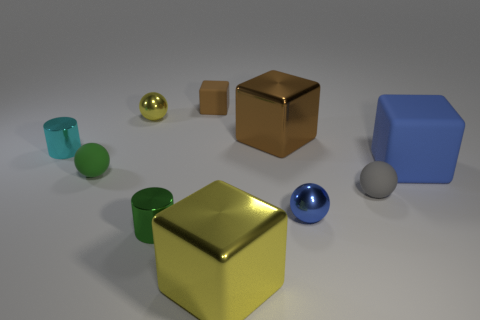There is a cyan object; what shape is it?
Give a very brief answer. Cylinder. What number of small green spheres are on the left side of the small metallic cylinder to the right of the small sphere behind the tiny green ball?
Provide a short and direct response. 1. What number of other objects are the same material as the tiny yellow thing?
Your answer should be very brief. 5. There is a brown thing that is the same size as the blue matte thing; what is it made of?
Provide a short and direct response. Metal. There is a metal cylinder behind the gray matte object; does it have the same color as the small matte sphere that is to the left of the yellow metallic block?
Ensure brevity in your answer.  No. Are there any small green rubber objects of the same shape as the tiny gray rubber thing?
Provide a succinct answer. Yes. There is a brown shiny object that is the same size as the blue block; what is its shape?
Provide a succinct answer. Cube. How many large metal cubes are the same color as the small block?
Offer a very short reply. 1. What size is the sphere behind the tiny cyan cylinder?
Offer a very short reply. Small. What number of metallic things are the same size as the green cylinder?
Ensure brevity in your answer.  3. 